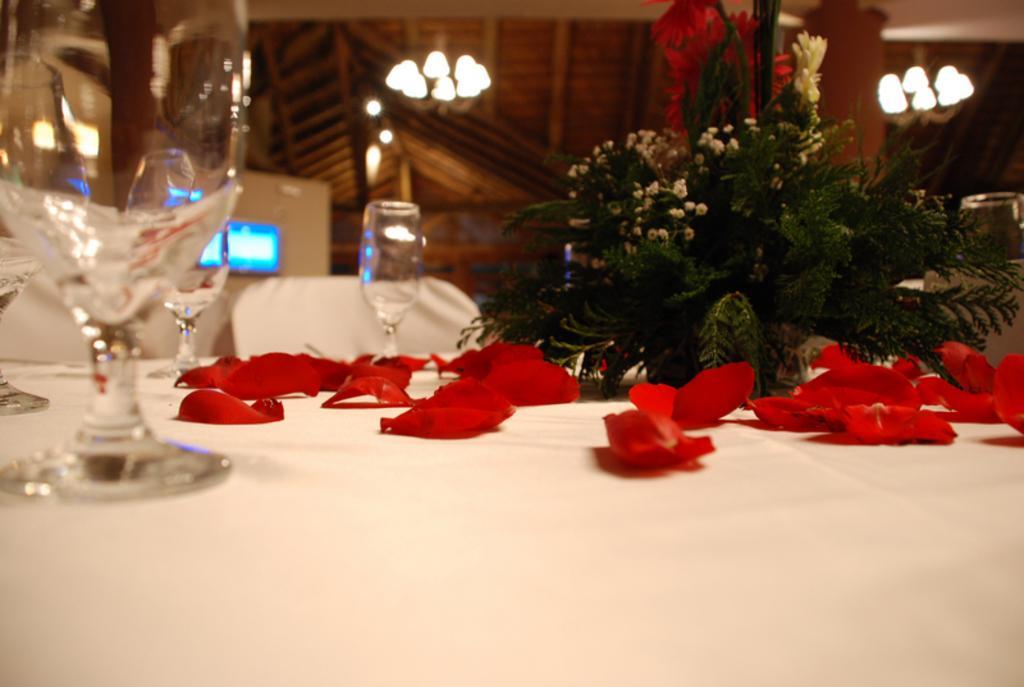Describe this image in one or two sentences. In this image I can see rose petals, wine glasses on a white table. There is a bouquet and there are lights at the top. There are screens at the back. 